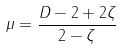<formula> <loc_0><loc_0><loc_500><loc_500>\mu = \frac { D - 2 + 2 \zeta } { 2 - \zeta }</formula> 